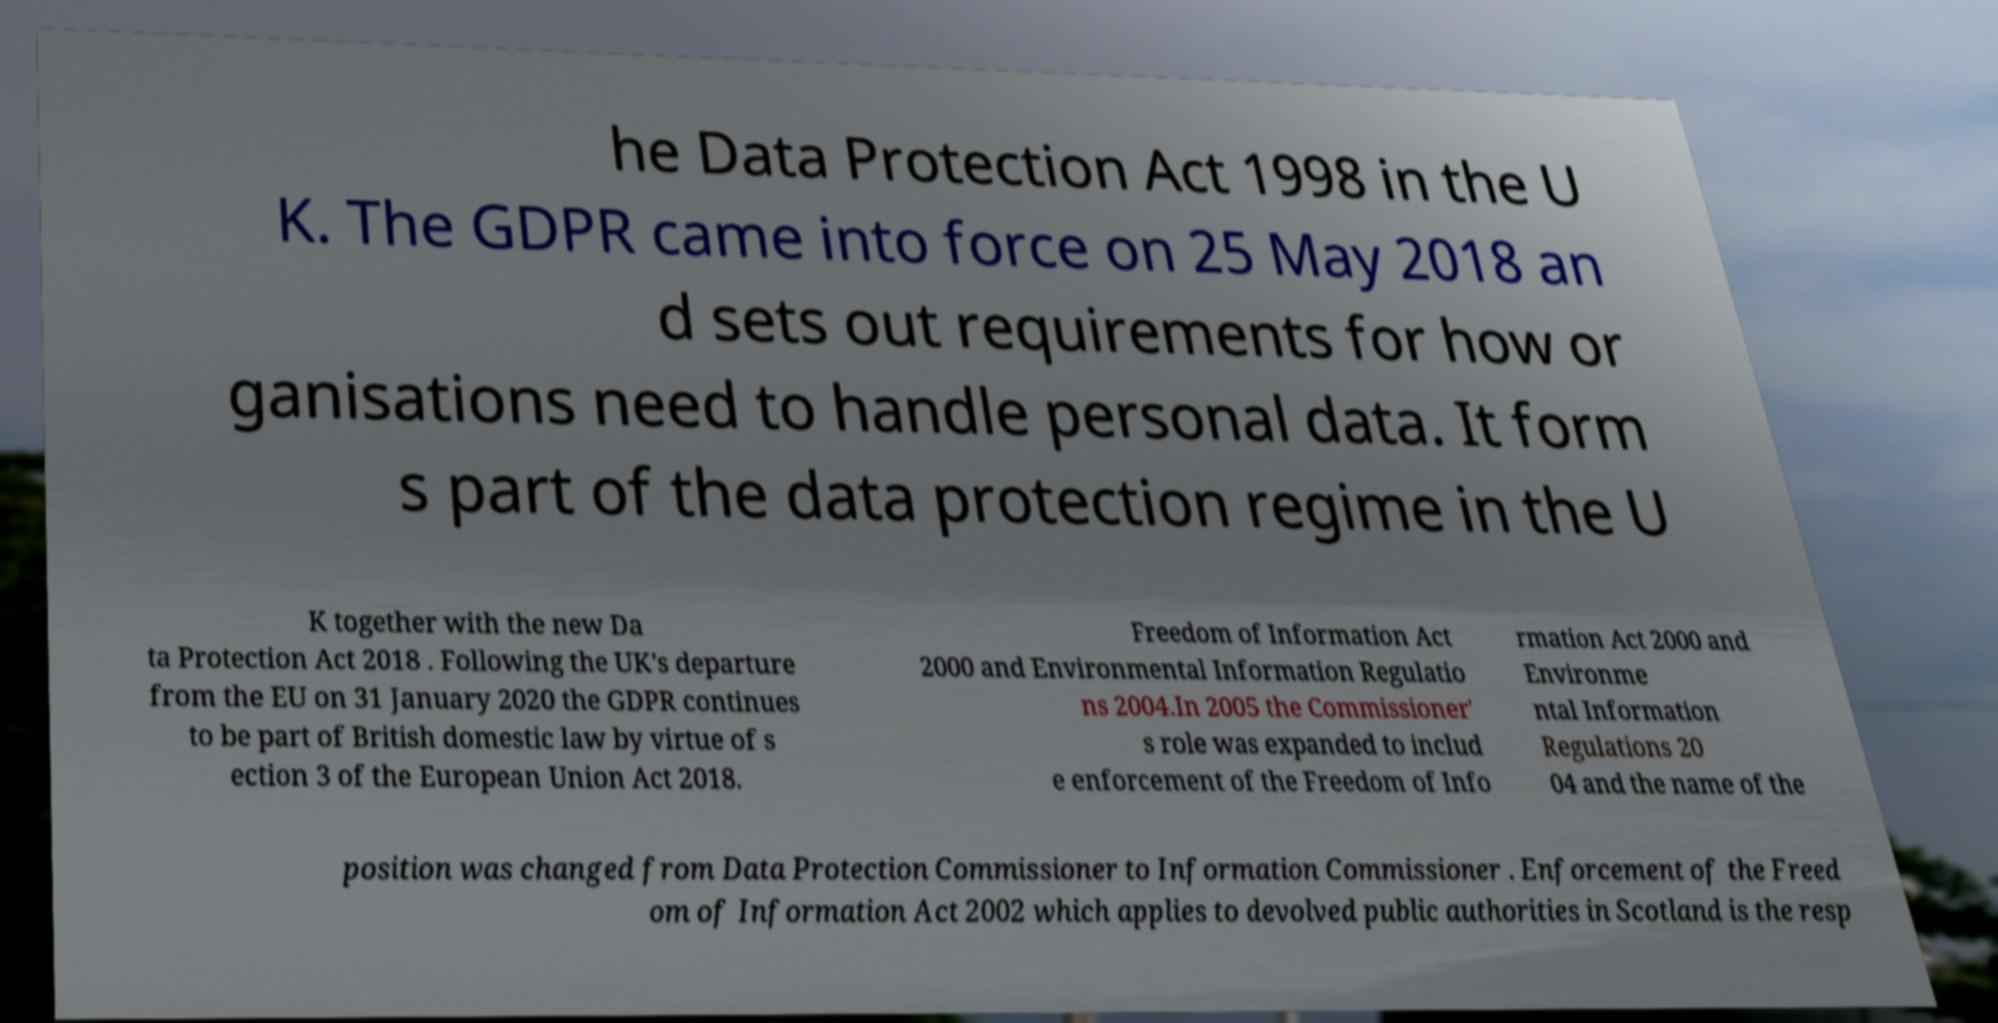What messages or text are displayed in this image? I need them in a readable, typed format. he Data Protection Act 1998 in the U K. The GDPR came into force on 25 May 2018 an d sets out requirements for how or ganisations need to handle personal data. It form s part of the data protection regime in the U K together with the new Da ta Protection Act 2018 . Following the UK's departure from the EU on 31 January 2020 the GDPR continues to be part of British domestic law by virtue of s ection 3 of the European Union Act 2018. Freedom of Information Act 2000 and Environmental Information Regulatio ns 2004.In 2005 the Commissioner' s role was expanded to includ e enforcement of the Freedom of Info rmation Act 2000 and Environme ntal Information Regulations 20 04 and the name of the position was changed from Data Protection Commissioner to Information Commissioner . Enforcement of the Freed om of Information Act 2002 which applies to devolved public authorities in Scotland is the resp 